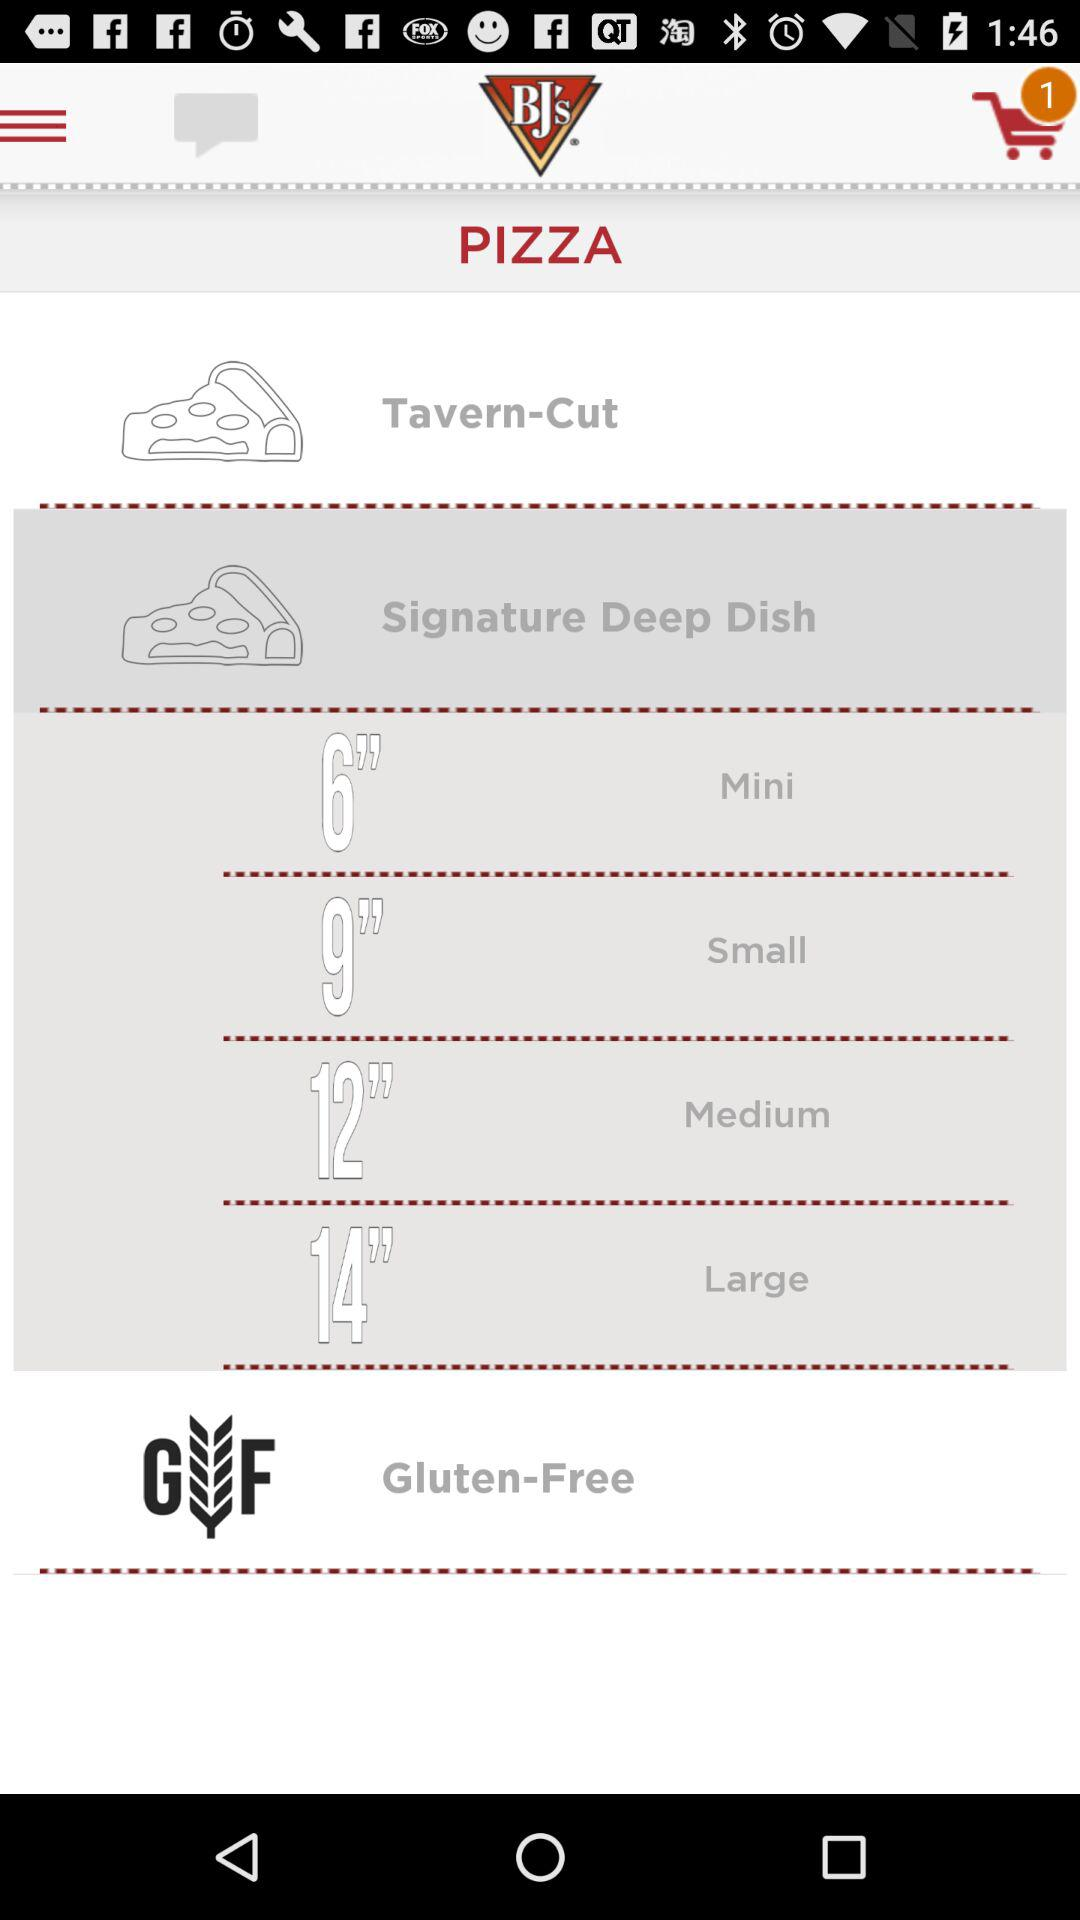What are the names of the different pizzas? The names of the different pizzas are Tavern-Cut and Signature Deep Dish. 